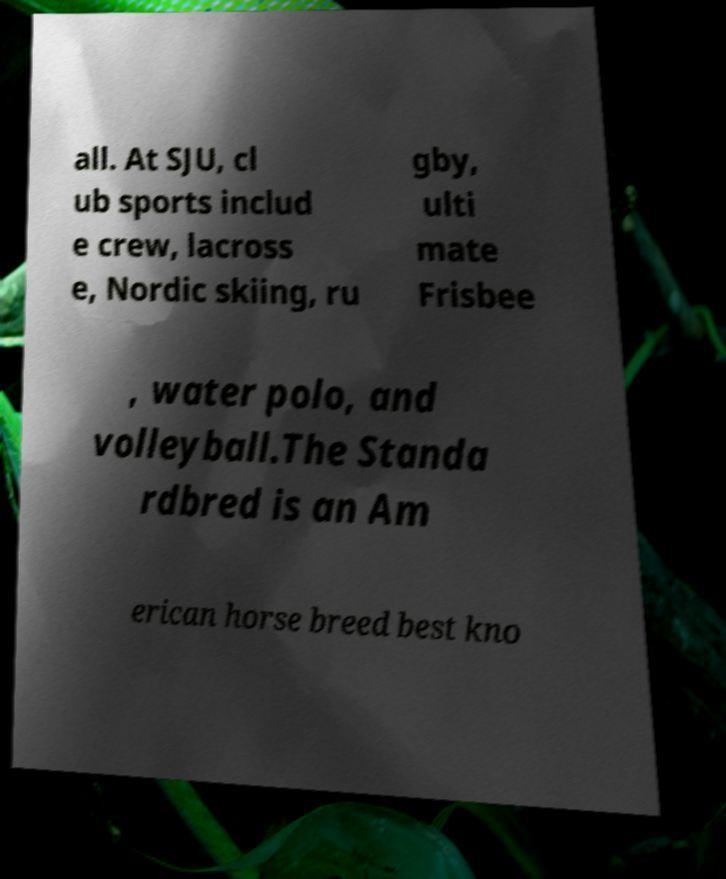What messages or text are displayed in this image? I need them in a readable, typed format. all. At SJU, cl ub sports includ e crew, lacross e, Nordic skiing, ru gby, ulti mate Frisbee , water polo, and volleyball.The Standa rdbred is an Am erican horse breed best kno 